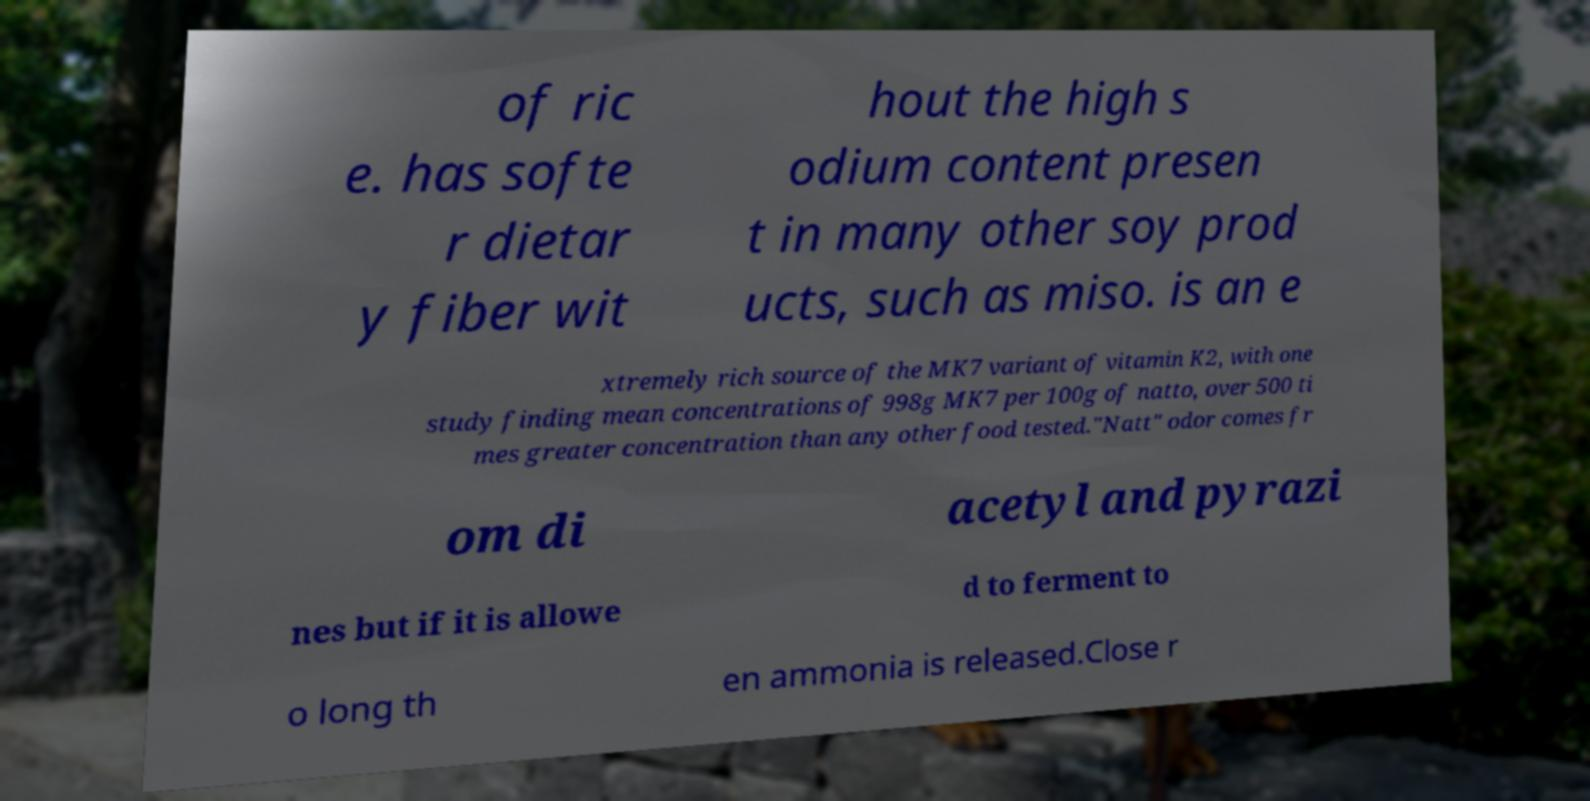Can you accurately transcribe the text from the provided image for me? of ric e. has softe r dietar y fiber wit hout the high s odium content presen t in many other soy prod ucts, such as miso. is an e xtremely rich source of the MK7 variant of vitamin K2, with one study finding mean concentrations of 998g MK7 per 100g of natto, over 500 ti mes greater concentration than any other food tested."Natt" odor comes fr om di acetyl and pyrazi nes but if it is allowe d to ferment to o long th en ammonia is released.Close r 